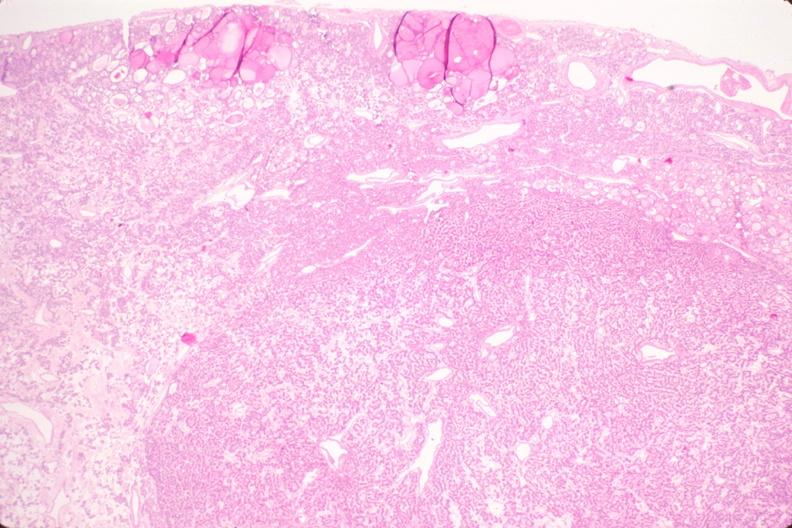s side present?
Answer the question using a single word or phrase. No 